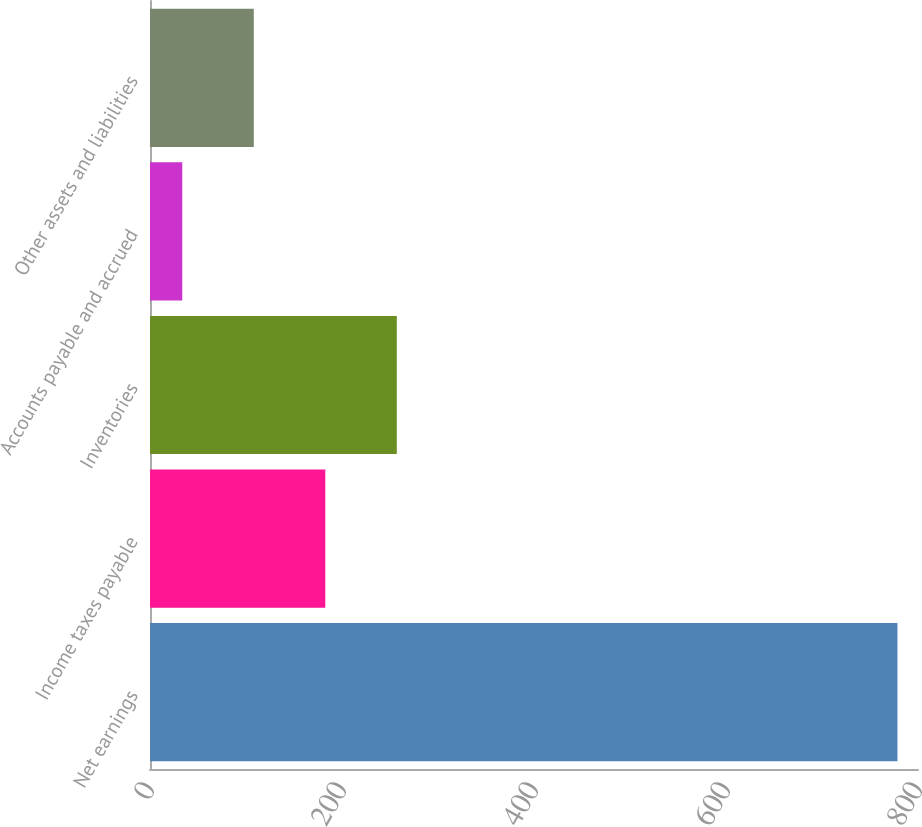<chart> <loc_0><loc_0><loc_500><loc_500><bar_chart><fcel>Net earnings<fcel>Income taxes payable<fcel>Inventories<fcel>Accounts payable and accrued<fcel>Other assets and liabilities<nl><fcel>778.6<fcel>182.6<fcel>257.1<fcel>33.6<fcel>108.1<nl></chart> 